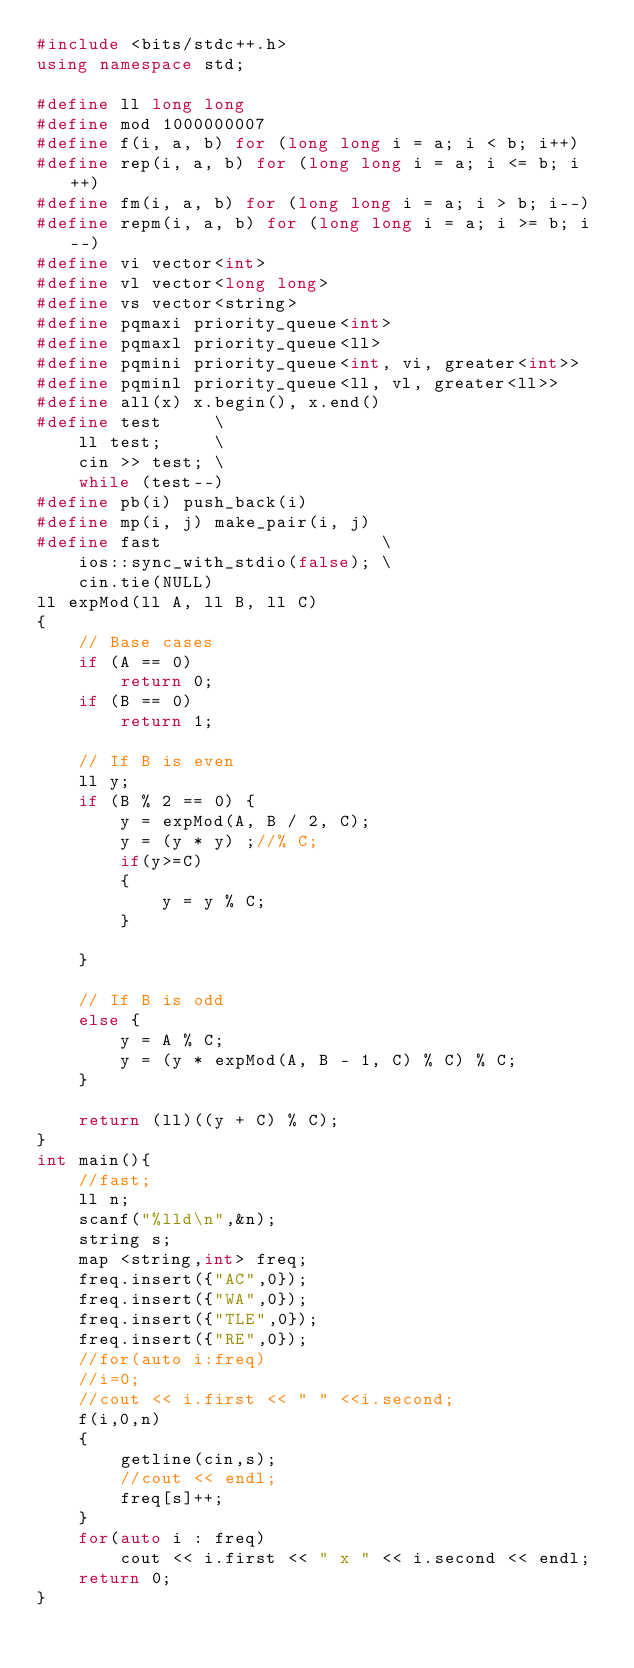<code> <loc_0><loc_0><loc_500><loc_500><_C++_>#include <bits/stdc++.h>
using namespace std;

#define ll long long
#define mod 1000000007
#define f(i, a, b) for (long long i = a; i < b; i++)
#define rep(i, a, b) for (long long i = a; i <= b; i++)
#define fm(i, a, b) for (long long i = a; i > b; i--)
#define repm(i, a, b) for (long long i = a; i >= b; i--)
#define vi vector<int>
#define vl vector<long long>
#define vs vector<string>
#define pqmaxi priority_queue<int>
#define pqmaxl priority_queue<ll>
#define pqmini priority_queue<int, vi, greater<int>>
#define pqminl priority_queue<ll, vl, greater<ll>>
#define all(x) x.begin(), x.end()
#define test     \
    ll test;     \
    cin >> test; \
    while (test--)
#define pb(i) push_back(i)
#define mp(i, j) make_pair(i, j)
#define fast                     \
    ios::sync_with_stdio(false); \
    cin.tie(NULL)
ll expMod(ll A, ll B, ll C)
{
    // Base cases
    if (A == 0)
        return 0;
    if (B == 0)
        return 1;

    // If B is even
    ll y;
    if (B % 2 == 0) {
        y = expMod(A, B / 2, C);
        y = (y * y) ;//% C;
        if(y>=C)
        {
            y = y % C;
        }

    }

    // If B is odd
    else {
        y = A % C;
        y = (y * expMod(A, B - 1, C) % C) % C;
    }

    return (ll)((y + C) % C);
}
int main(){
    //fast;
    ll n;
    scanf("%lld\n",&n);
    string s;
    map <string,int> freq;
    freq.insert({"AC",0});
    freq.insert({"WA",0});
    freq.insert({"TLE",0});
    freq.insert({"RE",0});
    //for(auto i:freq)
    //i=0;
    //cout << i.first << " " <<i.second;
    f(i,0,n)
    {
        getline(cin,s);
        //cout << endl;
        freq[s]++;
    }
    for(auto i : freq)
        cout << i.first << " x " << i.second << endl;
    return 0;
}
</code> 